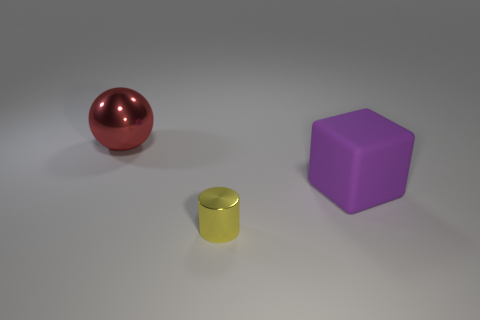Add 3 tiny yellow spheres. How many objects exist? 6 Subtract all cylinders. How many objects are left? 2 Add 3 purple rubber cubes. How many purple rubber cubes exist? 4 Subtract 0 blue blocks. How many objects are left? 3 Subtract all big things. Subtract all tiny cyan spheres. How many objects are left? 1 Add 3 big rubber objects. How many big rubber objects are left? 4 